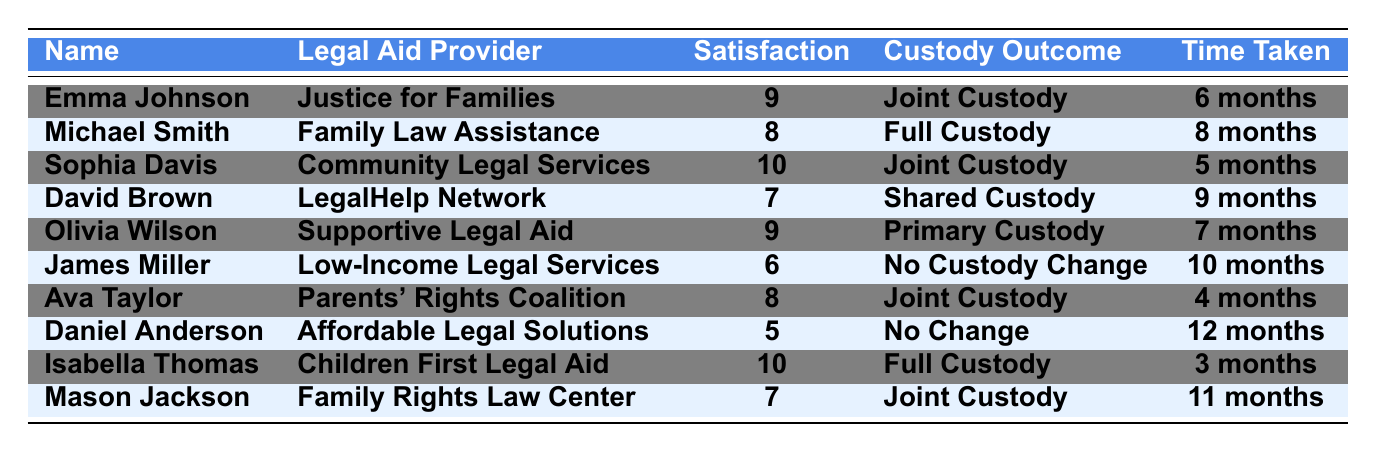What is the highest satisfaction rating among the parents? The table lists satisfaction ratings for each parent, and the highest number visible is 10, seen in the entries for Sophia Davis and Isabella Thomas.
Answer: 10 Who received full custody after using legal aid services? Looking through the table, the parents who achieved full custody are Michael Smith and Isabella Thomas.
Answer: Michael Smith and Isabella Thomas How long did Emma Johnson take to resolve her custody case? The table indicates the time taken for Emma Johnson's custody case resolution is listed as 6 months.
Answer: 6 months What is the satisfaction rating of Daniel Anderson? Referring to the table, Daniel Anderson's satisfaction rating is 5.
Answer: 5 Which legal aid provider helped the parent with the highest satisfaction rating? Sophia Davis and Isabella Thomas both have the highest satisfaction rating of 10, and both used different legal aid providers, namely Community Legal Services and Children First Legal Aid, respectively.
Answer: Community Legal Services and Children First Legal Aid How many parents reported a satisfaction rating of 8 or above? The table shows the following satisfaction ratings: 9 (two parents), 10 (two parents), and 8 (two parents), giving a total of 6 parents with satisfaction ratings of 8 or above.
Answer: 6 Is the average satisfaction rating for the group above 7? To find the average, add all the satisfaction ratings (9 + 8 + 10 + 7 + 9 + 6 + 8 + 5 + 10 + 7) = 79. There are 10 parents, so 79/10 = 7.9, which is above 7.
Answer: Yes What is the most common custody outcome reported by parents? Reviewing the custody outcomes in the table, "Joint Custody" appears four times, which is more frequent than any other outcome.
Answer: Joint Custody Did any parent experience no change in custody status? Yes, looking at the data, James Miller and Daniel Anderson both had "No Custody Change" as their outcome.
Answer: Yes What was the time taken by the parent with the lowest satisfaction rating? Daniel Anderson has the lowest satisfaction rating of 5, and the time taken for his case was 12 months, as noted in the table.
Answer: 12 months 